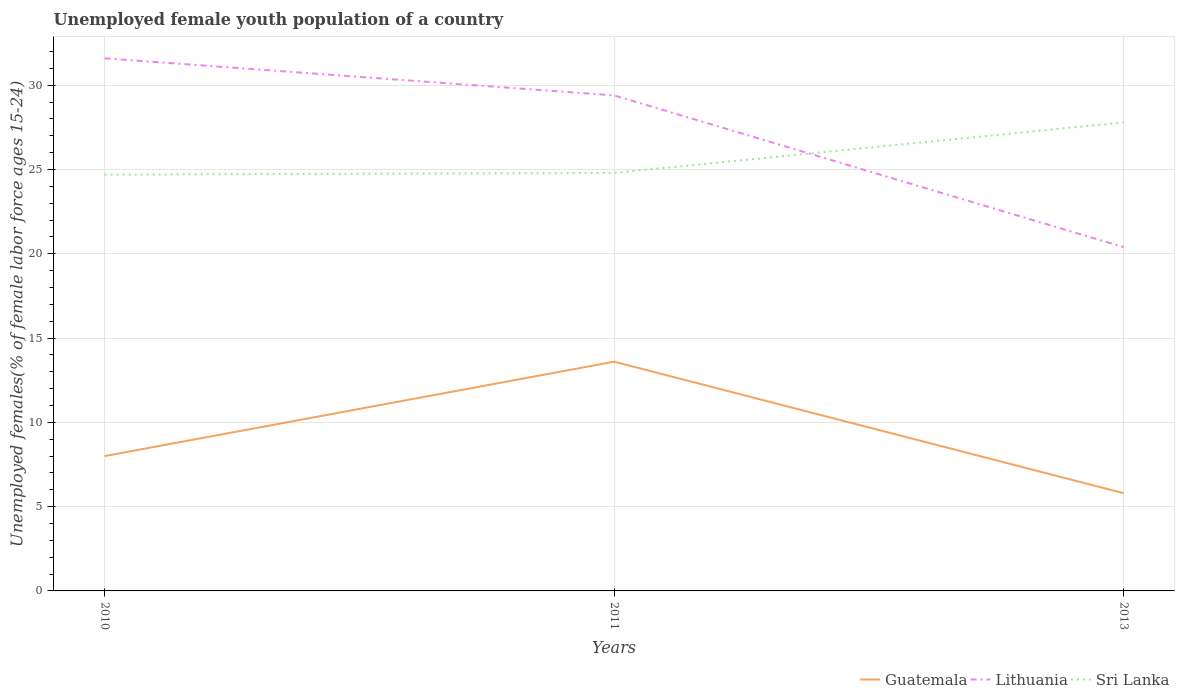Is the number of lines equal to the number of legend labels?
Your answer should be very brief. Yes. Across all years, what is the maximum percentage of unemployed female youth population in Guatemala?
Provide a short and direct response. 5.8. In which year was the percentage of unemployed female youth population in Lithuania maximum?
Keep it short and to the point. 2013. What is the total percentage of unemployed female youth population in Sri Lanka in the graph?
Keep it short and to the point. -3. What is the difference between the highest and the second highest percentage of unemployed female youth population in Guatemala?
Ensure brevity in your answer.  7.8. What is the difference between the highest and the lowest percentage of unemployed female youth population in Guatemala?
Keep it short and to the point. 1. Is the percentage of unemployed female youth population in Guatemala strictly greater than the percentage of unemployed female youth population in Lithuania over the years?
Make the answer very short. Yes. How many years are there in the graph?
Make the answer very short. 3. Are the values on the major ticks of Y-axis written in scientific E-notation?
Your answer should be very brief. No. Does the graph contain any zero values?
Your answer should be very brief. No. How are the legend labels stacked?
Offer a very short reply. Horizontal. What is the title of the graph?
Your answer should be very brief. Unemployed female youth population of a country. Does "Ethiopia" appear as one of the legend labels in the graph?
Make the answer very short. No. What is the label or title of the X-axis?
Offer a terse response. Years. What is the label or title of the Y-axis?
Provide a succinct answer. Unemployed females(% of female labor force ages 15-24). What is the Unemployed females(% of female labor force ages 15-24) in Guatemala in 2010?
Your response must be concise. 8. What is the Unemployed females(% of female labor force ages 15-24) of Lithuania in 2010?
Offer a very short reply. 31.6. What is the Unemployed females(% of female labor force ages 15-24) in Sri Lanka in 2010?
Offer a terse response. 24.7. What is the Unemployed females(% of female labor force ages 15-24) in Guatemala in 2011?
Make the answer very short. 13.6. What is the Unemployed females(% of female labor force ages 15-24) in Lithuania in 2011?
Keep it short and to the point. 29.4. What is the Unemployed females(% of female labor force ages 15-24) of Sri Lanka in 2011?
Your response must be concise. 24.8. What is the Unemployed females(% of female labor force ages 15-24) of Guatemala in 2013?
Provide a short and direct response. 5.8. What is the Unemployed females(% of female labor force ages 15-24) in Lithuania in 2013?
Your response must be concise. 20.4. What is the Unemployed females(% of female labor force ages 15-24) in Sri Lanka in 2013?
Give a very brief answer. 27.8. Across all years, what is the maximum Unemployed females(% of female labor force ages 15-24) of Guatemala?
Your response must be concise. 13.6. Across all years, what is the maximum Unemployed females(% of female labor force ages 15-24) of Lithuania?
Make the answer very short. 31.6. Across all years, what is the maximum Unemployed females(% of female labor force ages 15-24) in Sri Lanka?
Provide a succinct answer. 27.8. Across all years, what is the minimum Unemployed females(% of female labor force ages 15-24) of Guatemala?
Make the answer very short. 5.8. Across all years, what is the minimum Unemployed females(% of female labor force ages 15-24) of Lithuania?
Your answer should be very brief. 20.4. Across all years, what is the minimum Unemployed females(% of female labor force ages 15-24) of Sri Lanka?
Your answer should be compact. 24.7. What is the total Unemployed females(% of female labor force ages 15-24) in Guatemala in the graph?
Your answer should be very brief. 27.4. What is the total Unemployed females(% of female labor force ages 15-24) of Lithuania in the graph?
Provide a short and direct response. 81.4. What is the total Unemployed females(% of female labor force ages 15-24) in Sri Lanka in the graph?
Make the answer very short. 77.3. What is the difference between the Unemployed females(% of female labor force ages 15-24) in Guatemala in 2010 and that in 2011?
Offer a terse response. -5.6. What is the difference between the Unemployed females(% of female labor force ages 15-24) of Sri Lanka in 2010 and that in 2011?
Give a very brief answer. -0.1. What is the difference between the Unemployed females(% of female labor force ages 15-24) in Lithuania in 2010 and that in 2013?
Offer a terse response. 11.2. What is the difference between the Unemployed females(% of female labor force ages 15-24) of Guatemala in 2010 and the Unemployed females(% of female labor force ages 15-24) of Lithuania in 2011?
Your answer should be very brief. -21.4. What is the difference between the Unemployed females(% of female labor force ages 15-24) in Guatemala in 2010 and the Unemployed females(% of female labor force ages 15-24) in Sri Lanka in 2011?
Keep it short and to the point. -16.8. What is the difference between the Unemployed females(% of female labor force ages 15-24) in Lithuania in 2010 and the Unemployed females(% of female labor force ages 15-24) in Sri Lanka in 2011?
Your answer should be compact. 6.8. What is the difference between the Unemployed females(% of female labor force ages 15-24) in Guatemala in 2010 and the Unemployed females(% of female labor force ages 15-24) in Sri Lanka in 2013?
Make the answer very short. -19.8. What is the difference between the Unemployed females(% of female labor force ages 15-24) in Lithuania in 2010 and the Unemployed females(% of female labor force ages 15-24) in Sri Lanka in 2013?
Offer a very short reply. 3.8. What is the difference between the Unemployed females(% of female labor force ages 15-24) of Guatemala in 2011 and the Unemployed females(% of female labor force ages 15-24) of Sri Lanka in 2013?
Your answer should be very brief. -14.2. What is the difference between the Unemployed females(% of female labor force ages 15-24) of Lithuania in 2011 and the Unemployed females(% of female labor force ages 15-24) of Sri Lanka in 2013?
Your response must be concise. 1.6. What is the average Unemployed females(% of female labor force ages 15-24) in Guatemala per year?
Provide a succinct answer. 9.13. What is the average Unemployed females(% of female labor force ages 15-24) of Lithuania per year?
Keep it short and to the point. 27.13. What is the average Unemployed females(% of female labor force ages 15-24) in Sri Lanka per year?
Keep it short and to the point. 25.77. In the year 2010, what is the difference between the Unemployed females(% of female labor force ages 15-24) in Guatemala and Unemployed females(% of female labor force ages 15-24) in Lithuania?
Provide a short and direct response. -23.6. In the year 2010, what is the difference between the Unemployed females(% of female labor force ages 15-24) of Guatemala and Unemployed females(% of female labor force ages 15-24) of Sri Lanka?
Your answer should be compact. -16.7. In the year 2010, what is the difference between the Unemployed females(% of female labor force ages 15-24) in Lithuania and Unemployed females(% of female labor force ages 15-24) in Sri Lanka?
Provide a short and direct response. 6.9. In the year 2011, what is the difference between the Unemployed females(% of female labor force ages 15-24) in Guatemala and Unemployed females(% of female labor force ages 15-24) in Lithuania?
Your answer should be compact. -15.8. In the year 2011, what is the difference between the Unemployed females(% of female labor force ages 15-24) of Guatemala and Unemployed females(% of female labor force ages 15-24) of Sri Lanka?
Offer a very short reply. -11.2. In the year 2011, what is the difference between the Unemployed females(% of female labor force ages 15-24) in Lithuania and Unemployed females(% of female labor force ages 15-24) in Sri Lanka?
Provide a succinct answer. 4.6. In the year 2013, what is the difference between the Unemployed females(% of female labor force ages 15-24) in Guatemala and Unemployed females(% of female labor force ages 15-24) in Lithuania?
Ensure brevity in your answer.  -14.6. What is the ratio of the Unemployed females(% of female labor force ages 15-24) in Guatemala in 2010 to that in 2011?
Offer a terse response. 0.59. What is the ratio of the Unemployed females(% of female labor force ages 15-24) of Lithuania in 2010 to that in 2011?
Offer a very short reply. 1.07. What is the ratio of the Unemployed females(% of female labor force ages 15-24) in Guatemala in 2010 to that in 2013?
Provide a short and direct response. 1.38. What is the ratio of the Unemployed females(% of female labor force ages 15-24) in Lithuania in 2010 to that in 2013?
Offer a terse response. 1.55. What is the ratio of the Unemployed females(% of female labor force ages 15-24) of Sri Lanka in 2010 to that in 2013?
Provide a succinct answer. 0.89. What is the ratio of the Unemployed females(% of female labor force ages 15-24) of Guatemala in 2011 to that in 2013?
Offer a terse response. 2.34. What is the ratio of the Unemployed females(% of female labor force ages 15-24) in Lithuania in 2011 to that in 2013?
Your answer should be compact. 1.44. What is the ratio of the Unemployed females(% of female labor force ages 15-24) in Sri Lanka in 2011 to that in 2013?
Keep it short and to the point. 0.89. What is the difference between the highest and the second highest Unemployed females(% of female labor force ages 15-24) of Guatemala?
Offer a very short reply. 5.6. What is the difference between the highest and the second highest Unemployed females(% of female labor force ages 15-24) of Lithuania?
Your response must be concise. 2.2. What is the difference between the highest and the second highest Unemployed females(% of female labor force ages 15-24) of Sri Lanka?
Offer a terse response. 3. What is the difference between the highest and the lowest Unemployed females(% of female labor force ages 15-24) of Sri Lanka?
Offer a very short reply. 3.1. 